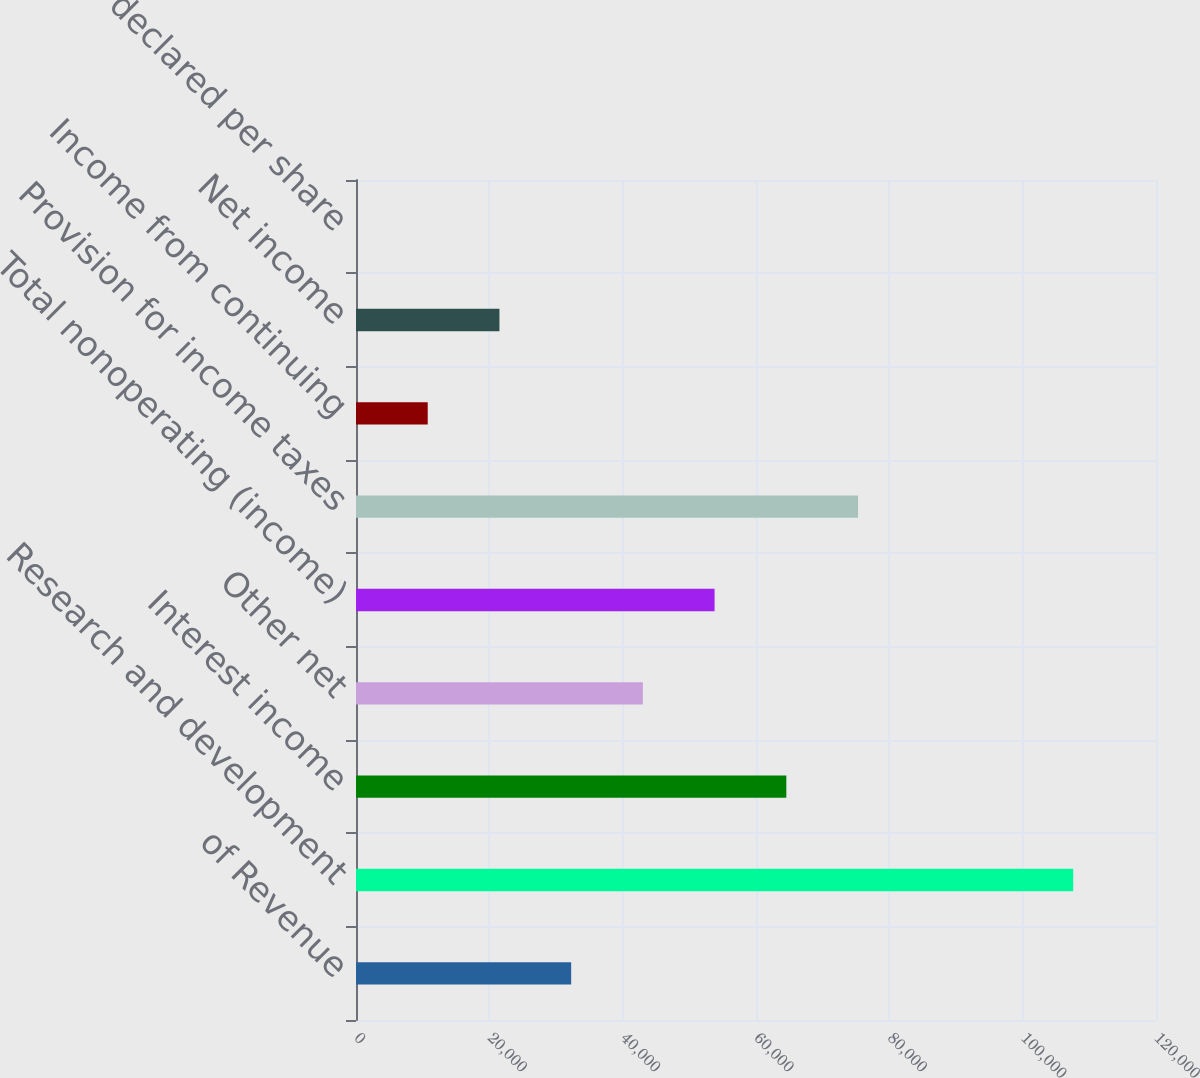Convert chart. <chart><loc_0><loc_0><loc_500><loc_500><bar_chart><fcel>of Revenue<fcel>Research and development<fcel>Interest income<fcel>Other net<fcel>Total nonoperating (income)<fcel>Provision for income taxes<fcel>Income from continuing<fcel>Net income<fcel>Dividends declared per share<nl><fcel>32273.5<fcel>107578<fcel>64546.9<fcel>43031.3<fcel>53789.1<fcel>75304.7<fcel>10758<fcel>21515.8<fcel>0.2<nl></chart> 